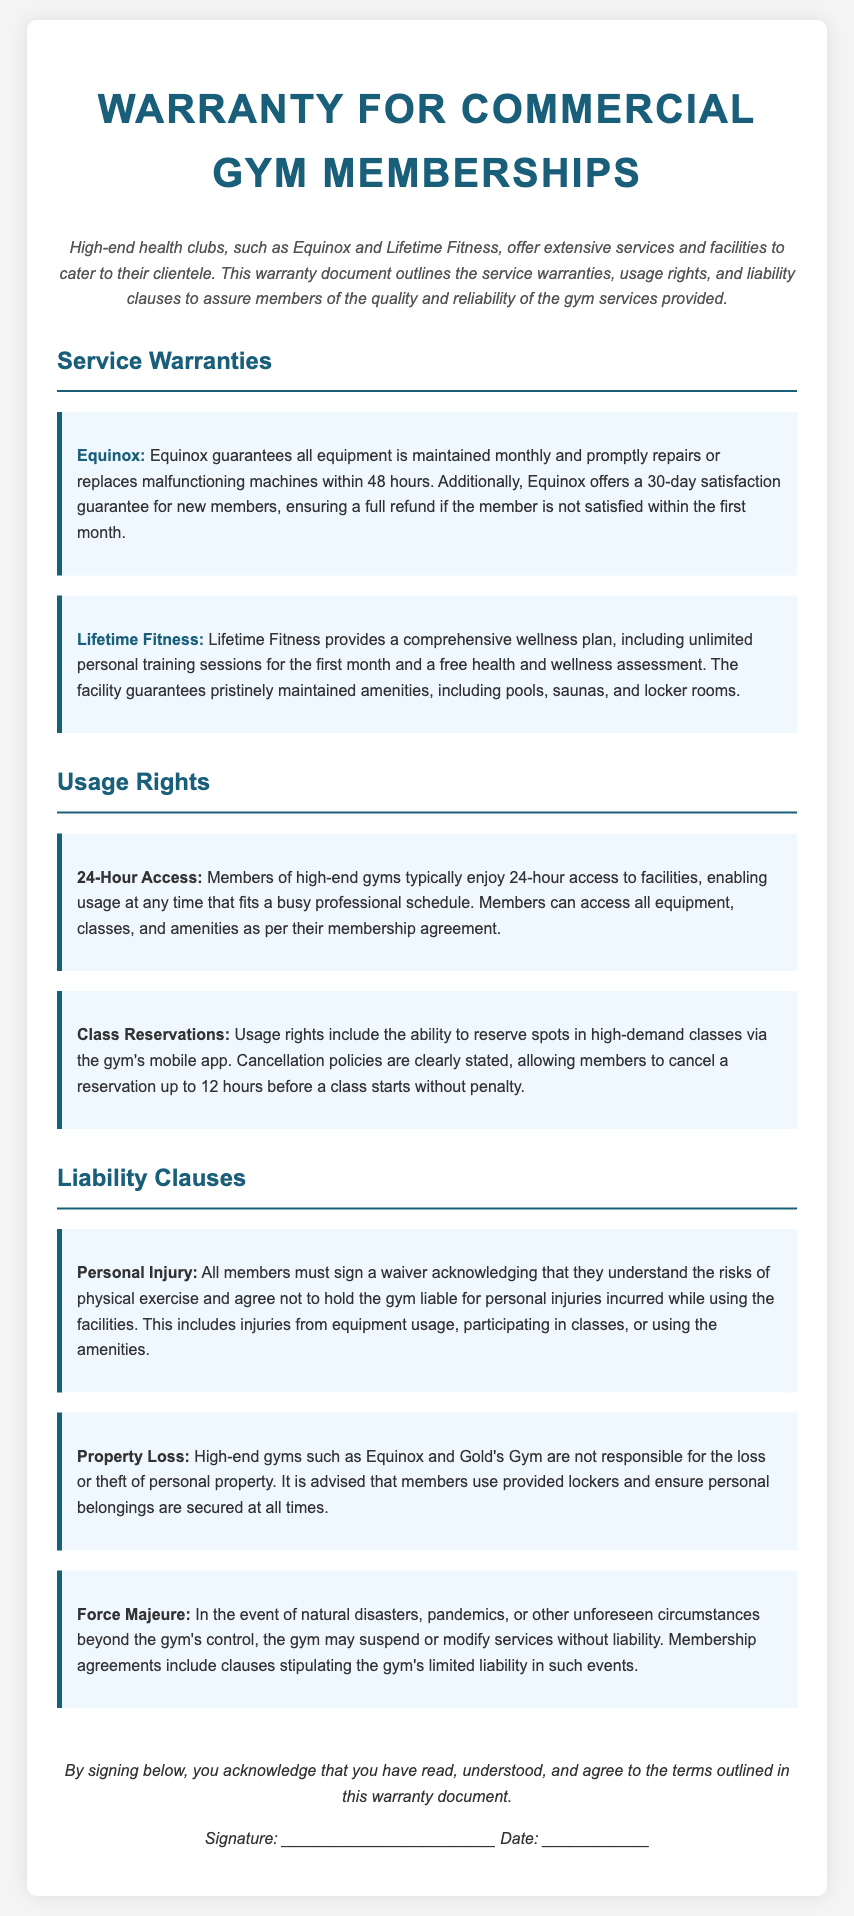What is the satisfaction guarantee period for new members at Equinox? The satisfaction guarantee for new members at Equinox is specified in the document, stating a full refund if not satisfied within the first month.
Answer: 30-day What wellness services does Lifetime Fitness provide for new members? The document outlines that Lifetime Fitness provides a comprehensive wellness plan, including unlimited personal training sessions and a free health and wellness assessment.
Answer: Unlimited personal training sessions and free health assessment What are the operating hours for high-end gyms mentioned in the warranty? The document clearly states that members typically enjoy 24-hour access to the facilities, which allows usage at any time.
Answer: 24-hour What is the cancellation policy for class reservations? The cancellation policy is detailed in the document, stating that members can cancel a reservation up to 12 hours before a class starts without penalty.
Answer: 12 hours What must members acknowledge regarding personal injuries? The document requires members to sign a waiver acknowledging the risks of physical exercise and agreeing not to hold the gym liable for personal injuries.
Answer: Waiver What are gyms not responsible for according to the liability clauses? The document mentions that high-end gyms are not responsible for the loss or theft of personal property.
Answer: Loss or theft of personal property What does the force majeure clause pertain to? The force majeure clause in the document addresses situations like natural disasters, pandemics, or other unforeseen circumstances beyond the gym's control.
Answer: Natural disasters and pandemics What is required for members to affirm their understanding of the warranty terms? The document specifies that members must sign below to acknowledge they have read, understood, and agree to the warranty terms.
Answer: Sign below 